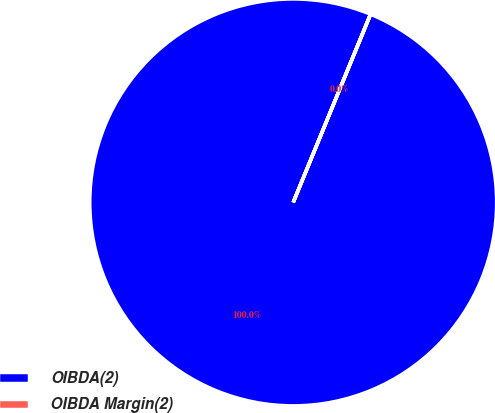Convert chart. <chart><loc_0><loc_0><loc_500><loc_500><pie_chart><fcel>OIBDA(2)<fcel>OIBDA Margin(2)<nl><fcel>99.99%<fcel>0.01%<nl></chart> 